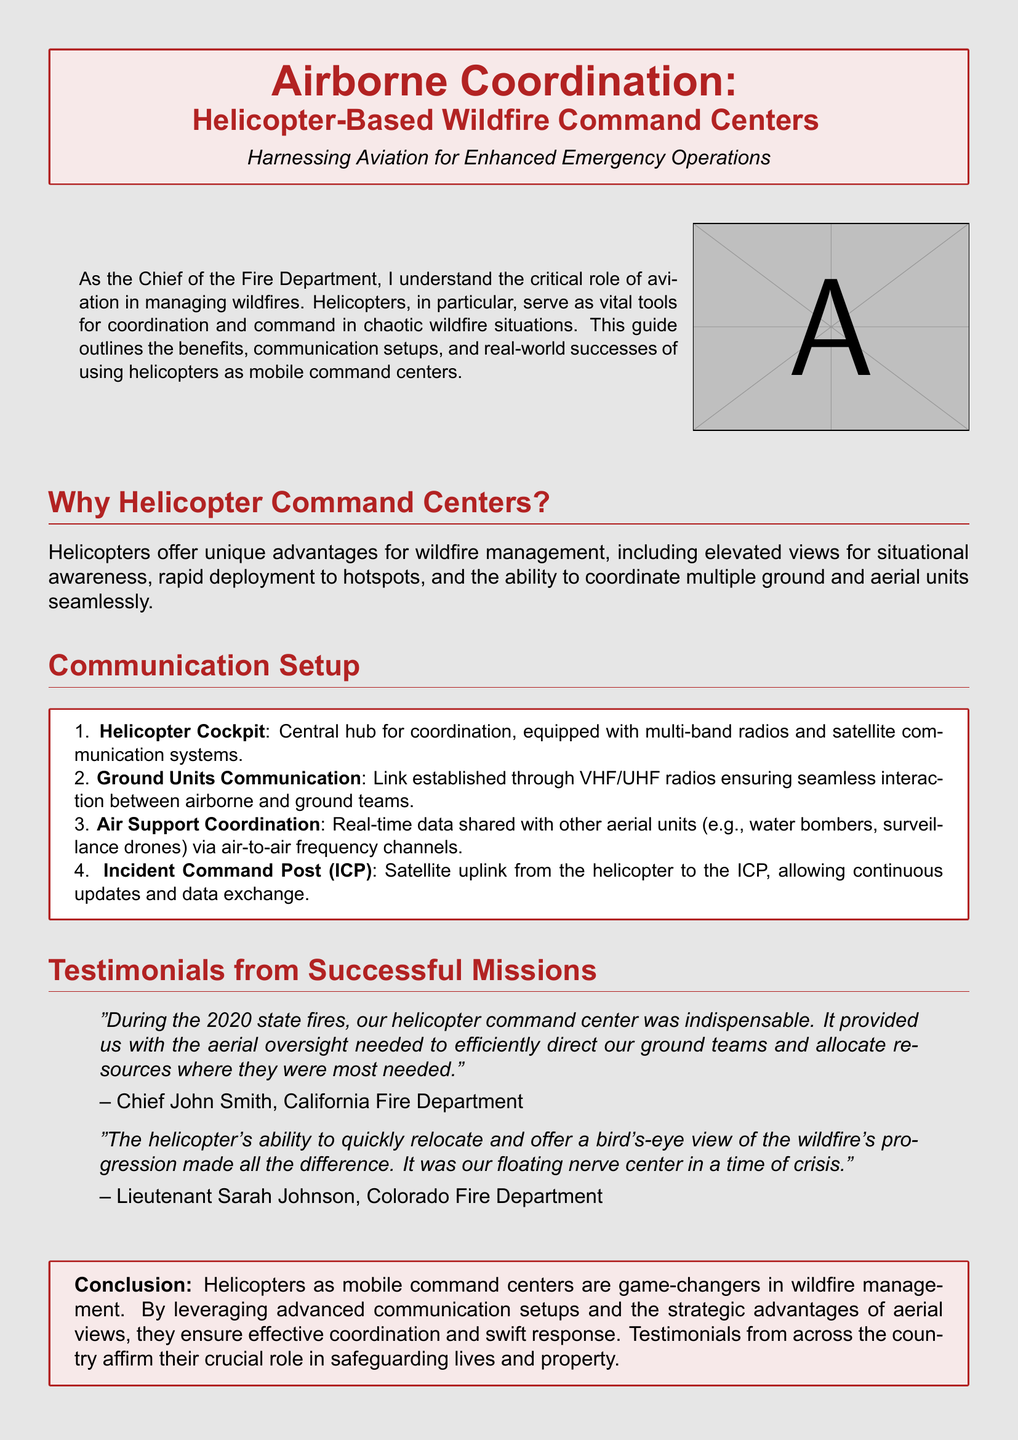What is the title of the document? The title is found at the top of the document in a prominent font style.
Answer: Airborne Coordination: Helicopter-Based Wildfire Command Centers What is one major benefit of using helicopters in wildfire management? The benefit is mentioned in the section "Why Helicopter Command Centers," highlighting the advantages of helicopters.
Answer: Elevated views for situational awareness What is the first component of the communication setup? The communication setup is outlined in a box, listing its components in a specific order.
Answer: Helicopter Cockpit Who provided a testimonial regarding the 2020 state fires? Testimonials are included in quotes, which specify the names and positions of the individuals.
Answer: Chief John Smith What year is mentioned in the testimonial about the helicopter command center? The year is referenced in a testimonial that discusses the effectiveness of the helicopter command center.
Answer: 2020 What color is used for the background of the document? The background color is described at the start of the document and sets the visual tone.
Answer: Smokey What is the role of the Incident Command Post (ICP) in the communication setup? The document describes the ICP's function in the communication setup section.
Answer: Satellite uplink from the helicopter What are the communication methods used with ground units? The methods are listed in the communication setup section, detailing interactions.
Answer: VHF/UHF radios How did Lieutenant Sarah Johnson describe the helicopter's role during wildfires? Her testimonial recounts the helicopter’s impact on situational oversight during crises.
Answer: Floating nerve center 